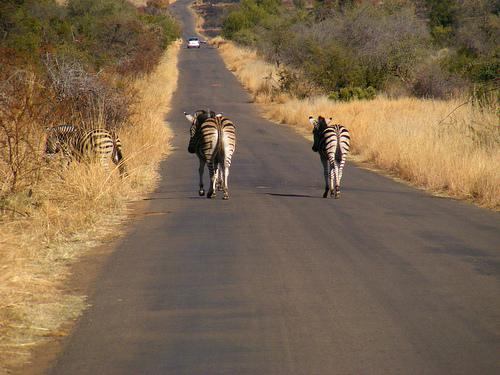Question: how many zebras?
Choices:
A. 3.
B. 4.
C. 5.
D. 6.
Answer with the letter. Answer: A Question: why are they walking?
Choices:
A. To find food.
B. To catch the bus.
C. To go to work.
D. Taking the dogs out.
Answer with the letter. Answer: A Question: what is brown?
Choices:
A. Grass.
B. The trees.
C. The bottle.
D. The dirt.
Answer with the letter. Answer: A Question: where is the car?
Choices:
A. In front of the zebras.
B. At the zoo.
C. In the parking lot.
D. In the driveway.
Answer with the letter. Answer: A Question: what is white?
Choices:
A. The house.
B. The car.
C. Zebras stripes.
D. The man.
Answer with the letter. Answer: C 